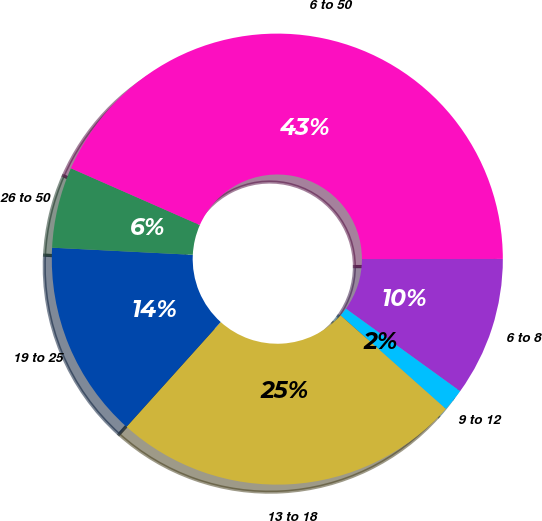Convert chart. <chart><loc_0><loc_0><loc_500><loc_500><pie_chart><fcel>6 to 8<fcel>9 to 12<fcel>13 to 18<fcel>19 to 25<fcel>26 to 50<fcel>6 to 50<nl><fcel>9.97%<fcel>1.61%<fcel>25.09%<fcel>14.15%<fcel>5.79%<fcel>43.39%<nl></chart> 